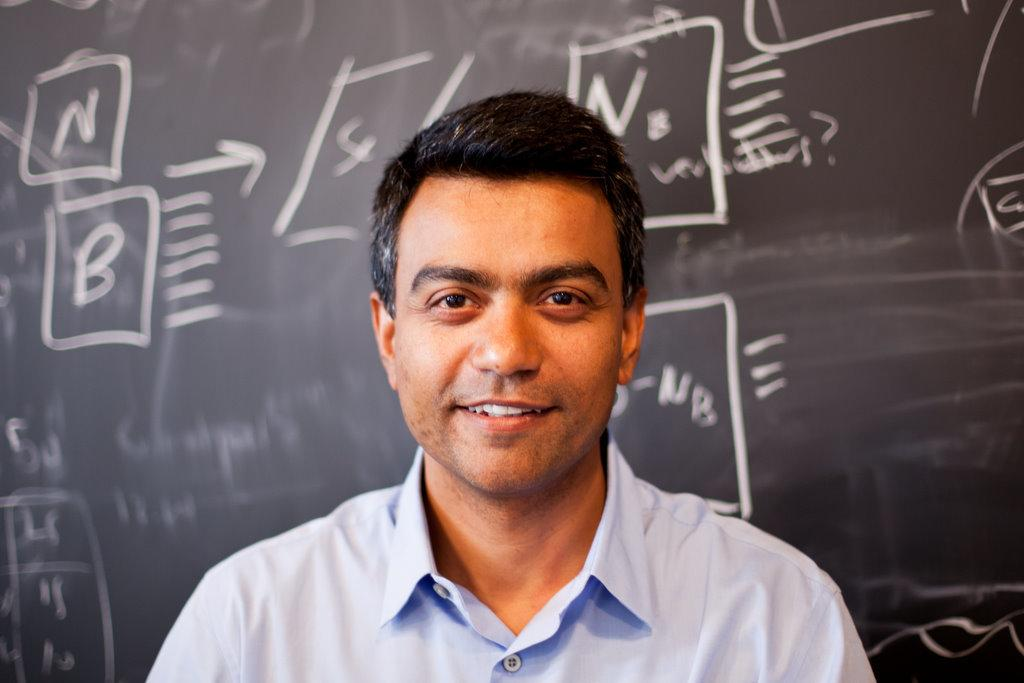Who is present in the image? There is a person in the image. What is the person wearing? The person is wearing a white shirt. What is the person's facial expression? The person is smiling. What object can be seen in the background of the image? There is a blackboard in the image. What is written on the blackboard? Something is written on the blackboard. What type of root can be seen growing on the person's shirt in the image? There is no root growing on the person's shirt in the image. What committee is responsible for the content written on the blackboard? The image does not provide information about a committee responsible for the content on the blackboard. 